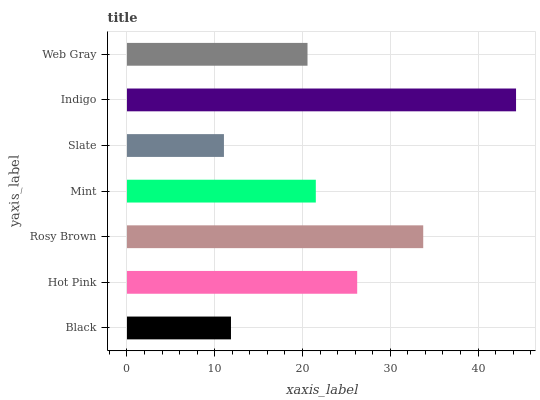Is Slate the minimum?
Answer yes or no. Yes. Is Indigo the maximum?
Answer yes or no. Yes. Is Hot Pink the minimum?
Answer yes or no. No. Is Hot Pink the maximum?
Answer yes or no. No. Is Hot Pink greater than Black?
Answer yes or no. Yes. Is Black less than Hot Pink?
Answer yes or no. Yes. Is Black greater than Hot Pink?
Answer yes or no. No. Is Hot Pink less than Black?
Answer yes or no. No. Is Mint the high median?
Answer yes or no. Yes. Is Mint the low median?
Answer yes or no. Yes. Is Indigo the high median?
Answer yes or no. No. Is Black the low median?
Answer yes or no. No. 